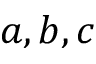<formula> <loc_0><loc_0><loc_500><loc_500>a , b , c</formula> 